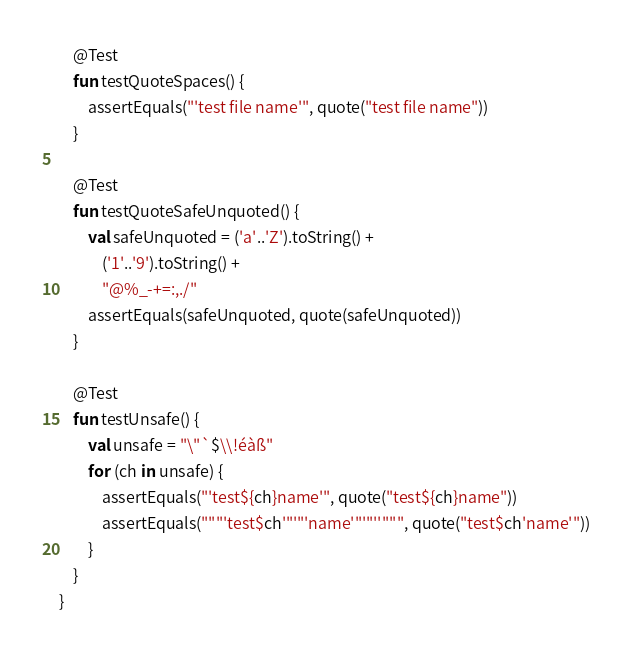<code> <loc_0><loc_0><loc_500><loc_500><_Kotlin_>
    @Test
    fun testQuoteSpaces() {
        assertEquals("'test file name'", quote("test file name"))
    }

    @Test
    fun testQuoteSafeUnquoted() {
        val safeUnquoted = ('a'..'Z').toString() +
            ('1'..'9').toString() +
            "@%_-+=:,./"
        assertEquals(safeUnquoted, quote(safeUnquoted))
    }

    @Test
    fun testUnsafe() {
        val unsafe = "\"`$\\!éàß"
        for (ch in unsafe) {
            assertEquals("'test${ch}name'", quote("test${ch}name"))
            assertEquals("""'test$ch'"'"'name'"'"''""", quote("test$ch'name'"))
        }
    }
}
</code> 